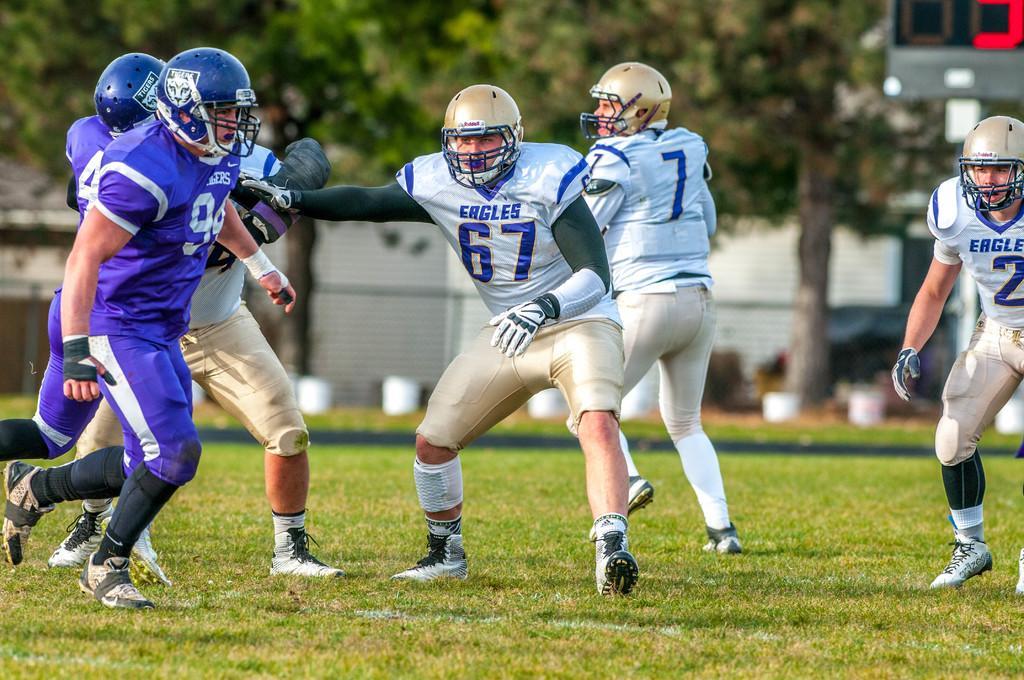Please provide a concise description of this image. In this image I can see there are persons visible on the ground and they are wearing a helmet and in the background I can see trees, building , vehicle , wall. 